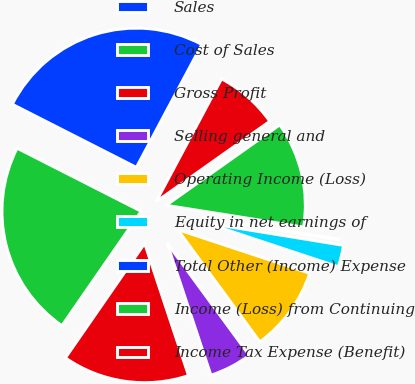<chart> <loc_0><loc_0><loc_500><loc_500><pie_chart><fcel>Sales<fcel>Cost of Sales<fcel>Gross Profit<fcel>Selling general and<fcel>Operating Income (Loss)<fcel>Equity in net earnings of<fcel>Total Other (Income) Expense<fcel>Income (Loss) from Continuing<fcel>Income Tax Expense (Benefit)<nl><fcel>25.3%<fcel>22.85%<fcel>14.74%<fcel>4.96%<fcel>9.85%<fcel>2.52%<fcel>0.07%<fcel>12.3%<fcel>7.41%<nl></chart> 